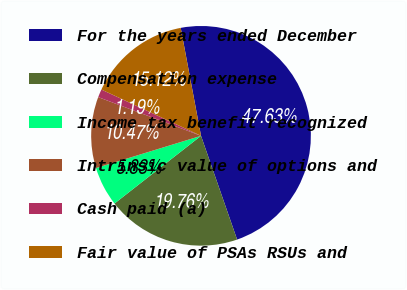Convert chart. <chart><loc_0><loc_0><loc_500><loc_500><pie_chart><fcel>For the years ended December<fcel>Compensation expense<fcel>Income tax benefit recognized<fcel>Intrinsic value of options and<fcel>Cash paid (a)<fcel>Fair value of PSAs RSUs and<nl><fcel>47.63%<fcel>19.76%<fcel>5.83%<fcel>10.47%<fcel>1.19%<fcel>15.12%<nl></chart> 